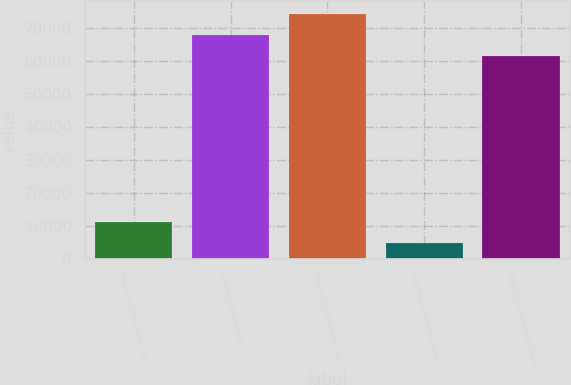Convert chart. <chart><loc_0><loc_0><loc_500><loc_500><bar_chart><fcel>Balance at the end of 2014<fcel>Goodwill recorded in<fcel>Balance at the end of 2015<fcel>Purchase price allocation<fcel>Balance at the end of 2016<nl><fcel>11232.8<fcel>67881.8<fcel>74227.6<fcel>4887<fcel>61536<nl></chart> 